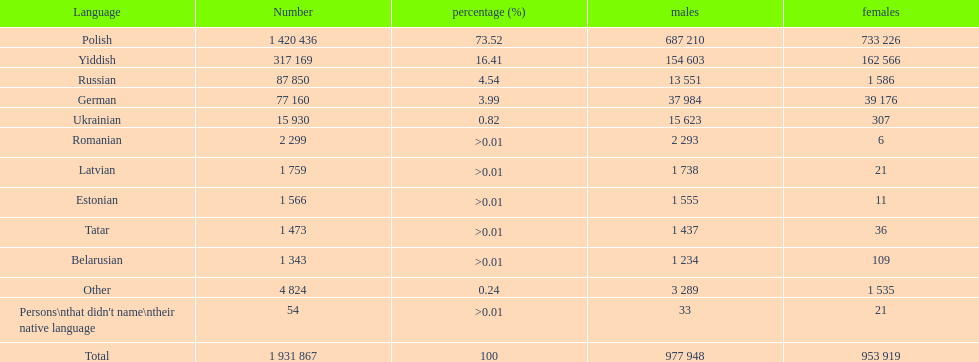What is the largest proportion of non-polish speakers? Yiddish. 